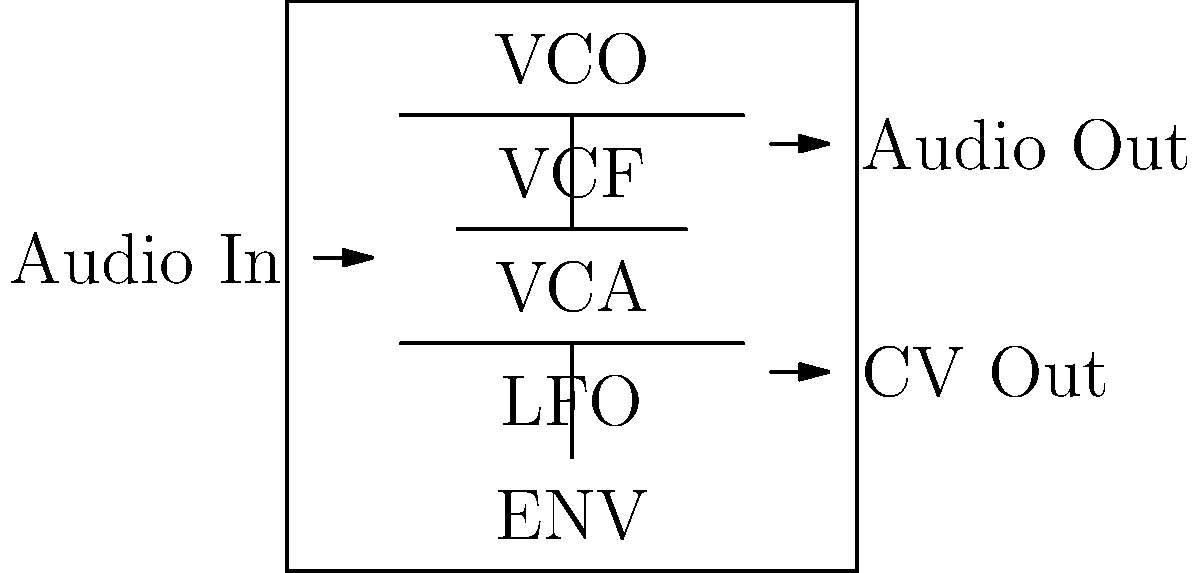In the given schematic of a vintage synthesizer, which component is responsible for shaping the overall amplitude envelope of the sound? To identify the component responsible for shaping the overall amplitude envelope of the sound in a vintage synthesizer, let's analyze the schematic step-by-step:

1. The schematic shows five main components of a typical analog synthesizer:
   - VCO (Voltage Controlled Oscillator)
   - VCF (Voltage Controlled Filter)
   - VCA (Voltage Controlled Amplifier)
   - LFO (Low Frequency Oscillator)
   - ENV (Envelope Generator)

2. The VCO generates the initial waveform of the sound.

3. The VCF shapes the harmonic content of the sound by filtering certain frequencies.

4. The VCA controls the overall amplitude of the sound.

5. The LFO produces low-frequency modulation signals that can be used to add movement to various parameters.

6. The ENV (Envelope Generator) is responsible for shaping the overall amplitude envelope of the sound over time.

7. In a typical ADSR (Attack, Decay, Sustain, Release) envelope:
   - Attack determines how quickly the sound reaches its maximum level
   - Decay sets how quickly the sound falls to the sustain level
   - Sustain defines the level at which the sound is held while a key is pressed
   - Release determines how quickly the sound fades out after the key is released

8. The ENV module sends control voltages to the VCA, which then shapes the overall amplitude of the sound according to the envelope settings.

Therefore, the component responsible for shaping the overall amplitude envelope of the sound in this vintage synthesizer schematic is the ENV (Envelope Generator).
Answer: ENV (Envelope Generator) 